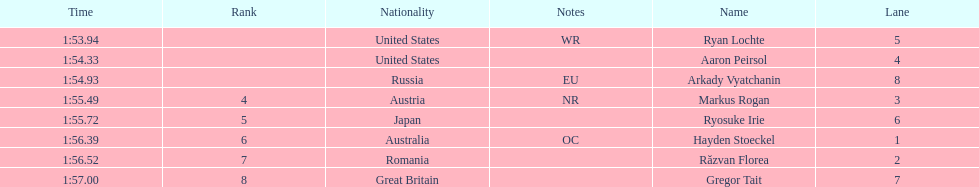Which country had the most medals in the competition? United States. 